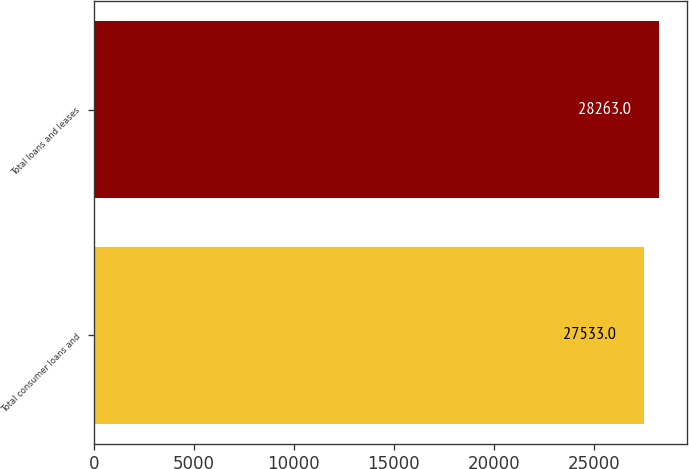Convert chart. <chart><loc_0><loc_0><loc_500><loc_500><bar_chart><fcel>Total consumer loans and<fcel>Total loans and leases<nl><fcel>27533<fcel>28263<nl></chart> 